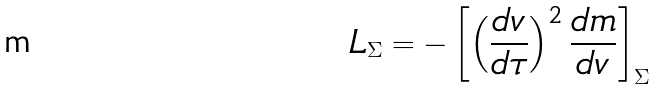Convert formula to latex. <formula><loc_0><loc_0><loc_500><loc_500>L _ { \Sigma } = - \left [ \left ( \frac { d v } { d \tau } \right ) ^ { 2 } \frac { d m } { d v } \right ] _ { \Sigma }</formula> 